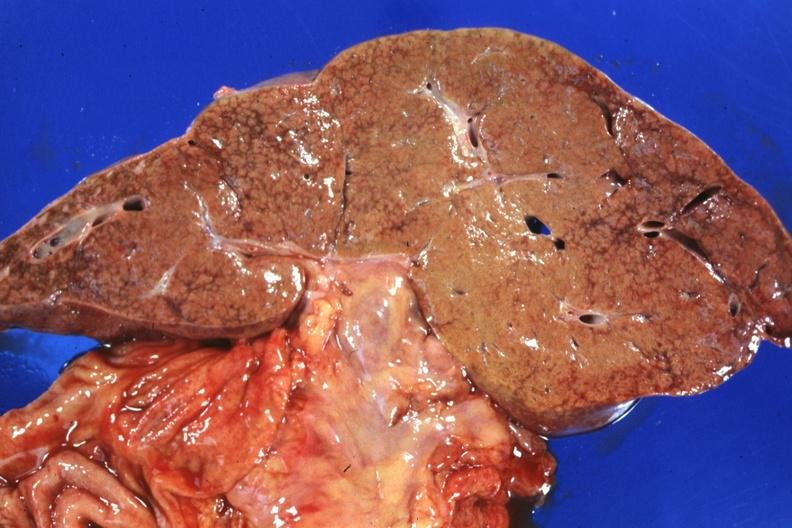s no tissue recognizable as ovary present?
Answer the question using a single word or phrase. No 